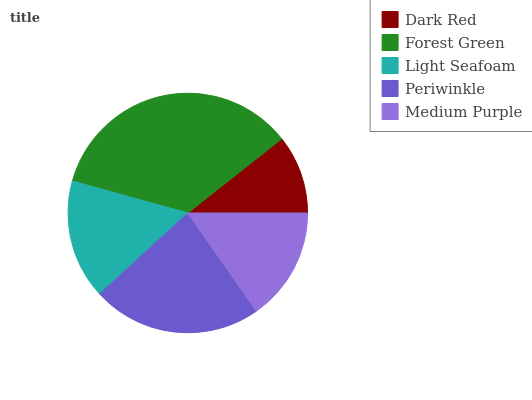Is Dark Red the minimum?
Answer yes or no. Yes. Is Forest Green the maximum?
Answer yes or no. Yes. Is Light Seafoam the minimum?
Answer yes or no. No. Is Light Seafoam the maximum?
Answer yes or no. No. Is Forest Green greater than Light Seafoam?
Answer yes or no. Yes. Is Light Seafoam less than Forest Green?
Answer yes or no. Yes. Is Light Seafoam greater than Forest Green?
Answer yes or no. No. Is Forest Green less than Light Seafoam?
Answer yes or no. No. Is Light Seafoam the high median?
Answer yes or no. Yes. Is Light Seafoam the low median?
Answer yes or no. Yes. Is Dark Red the high median?
Answer yes or no. No. Is Periwinkle the low median?
Answer yes or no. No. 